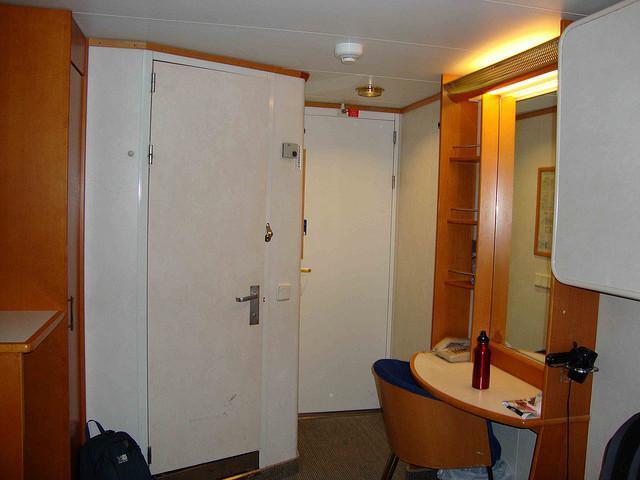How many plate mates are shown on the table?
Give a very brief answer. 0. How many backpacks can be seen?
Give a very brief answer. 1. How many people are in the poster on the wall?
Give a very brief answer. 0. 